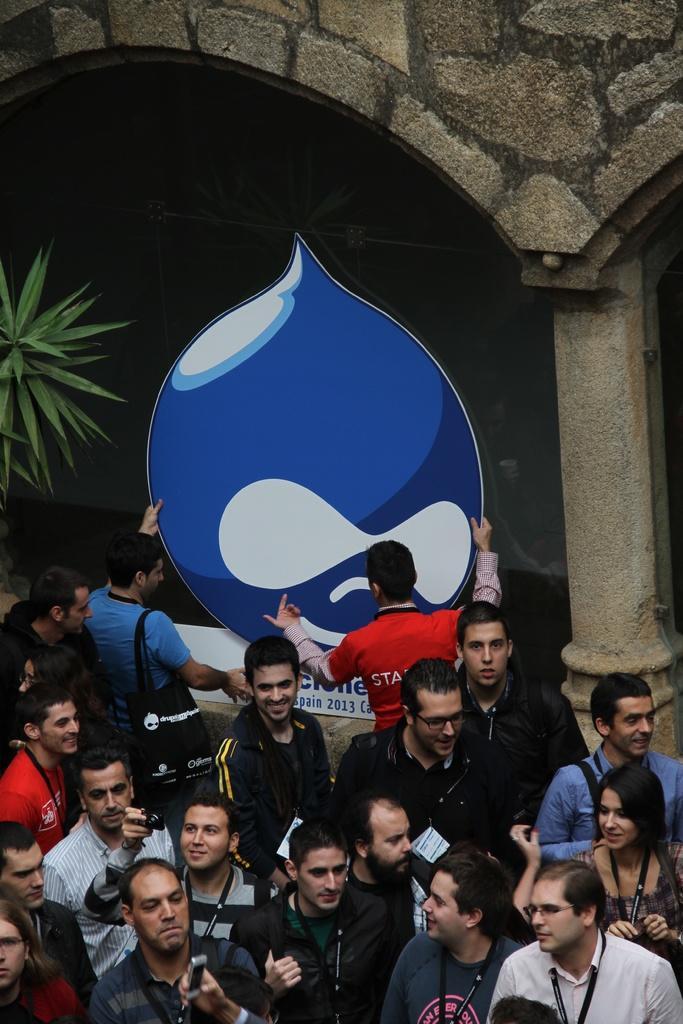Could you give a brief overview of what you see in this image? In this image we can see a few people, among them some are holding the objects, in the background, we can see a plant, pillar and the wall. 